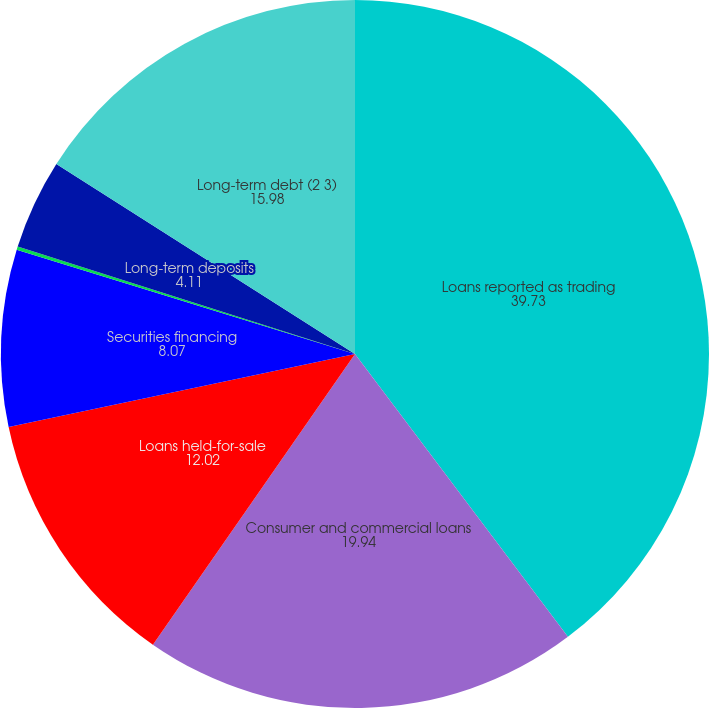Convert chart. <chart><loc_0><loc_0><loc_500><loc_500><pie_chart><fcel>Loans reported as trading<fcel>Consumer and commercial loans<fcel>Loans held-for-sale<fcel>Securities financing<fcel>Other assets<fcel>Long-term deposits<fcel>Long-term debt (2 3)<nl><fcel>39.73%<fcel>19.94%<fcel>12.02%<fcel>8.07%<fcel>0.15%<fcel>4.11%<fcel>15.98%<nl></chart> 